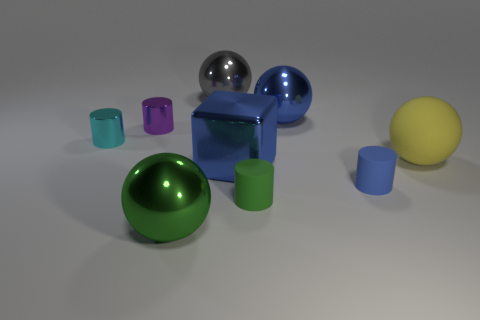Is the shape of the purple thing the same as the gray metallic object?
Ensure brevity in your answer.  No. There is a small cylinder that is the same color as the big metallic block; what is its material?
Give a very brief answer. Rubber. Do the large matte object and the shiny cube have the same color?
Provide a short and direct response. No. There is a small rubber thing that is to the left of the metallic object that is on the right side of the metal cube; what number of blue shiny things are left of it?
Provide a succinct answer. 1. What shape is the purple thing that is the same material as the green sphere?
Offer a very short reply. Cylinder. There is a blue object behind the tiny shiny cylinder to the right of the metallic cylinder that is in front of the tiny purple metal object; what is it made of?
Your answer should be very brief. Metal. How many things are either large metallic balls that are in front of the large gray metallic object or small metal things?
Offer a very short reply. 4. How many other objects are the same shape as the tiny purple thing?
Offer a very short reply. 3. Is the number of small purple things in front of the blue rubber cylinder greater than the number of big metal objects?
Your response must be concise. No. What is the size of the blue matte object that is the same shape as the green rubber object?
Keep it short and to the point. Small. 